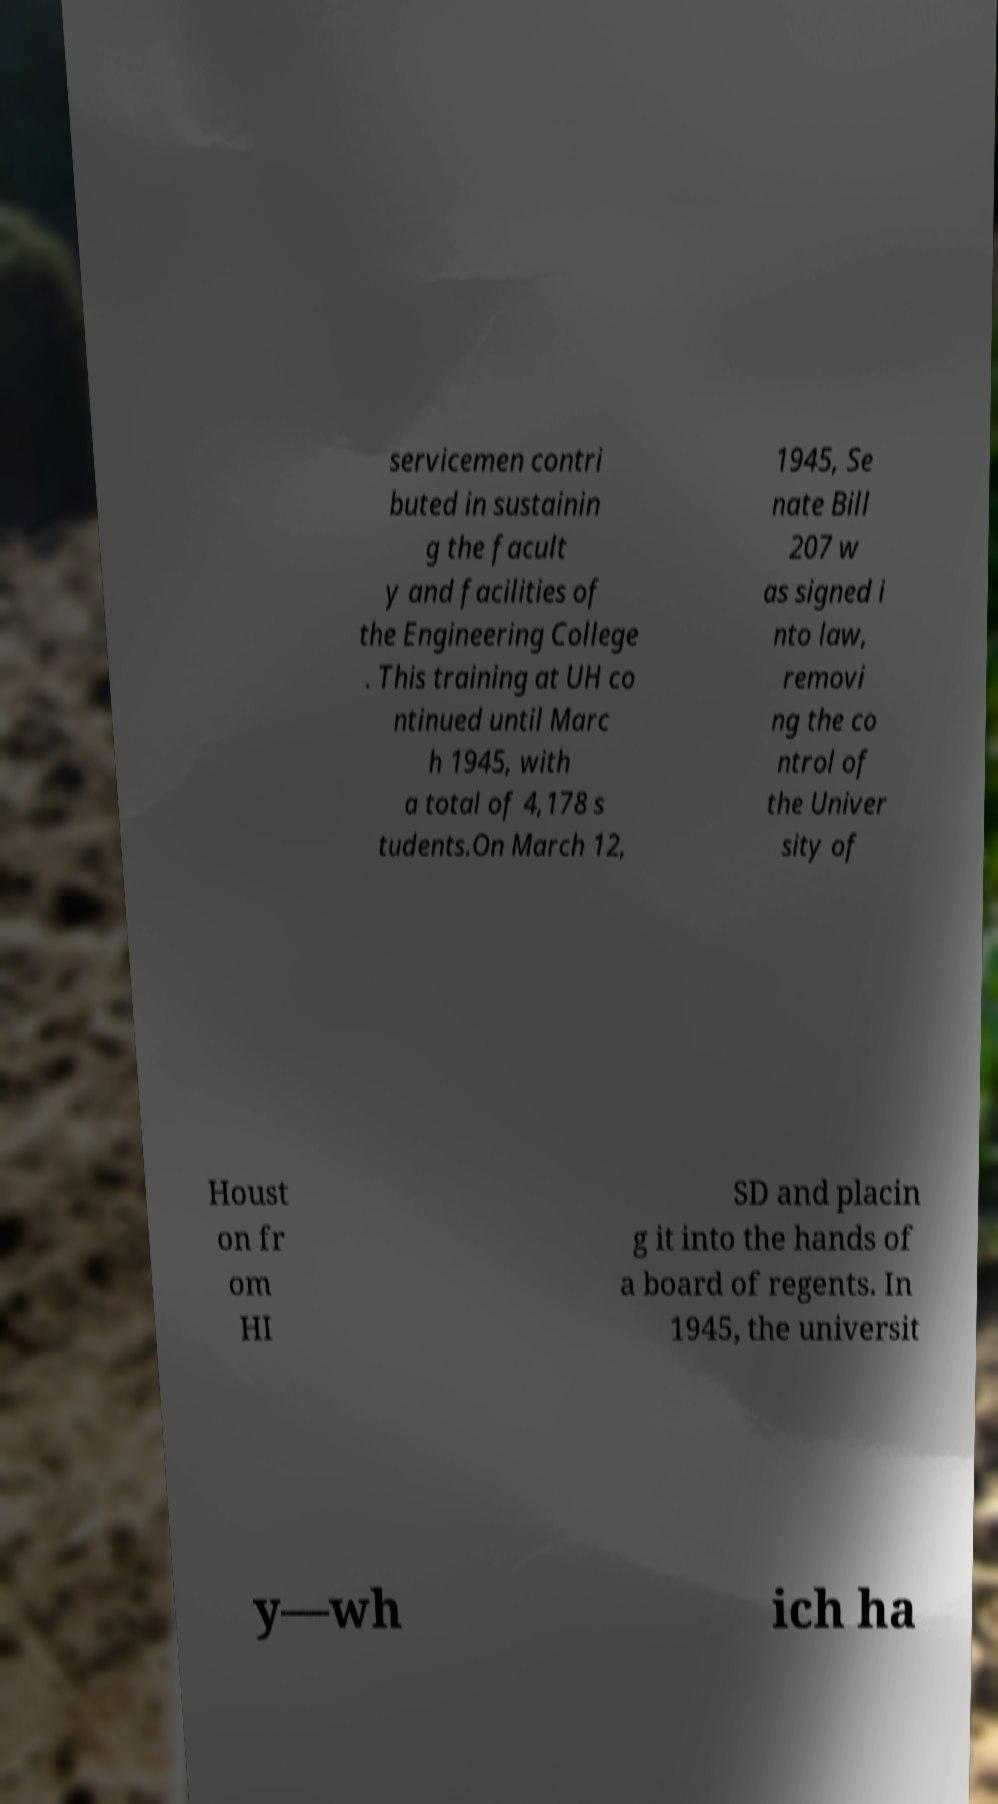I need the written content from this picture converted into text. Can you do that? servicemen contri buted in sustainin g the facult y and facilities of the Engineering College . This training at UH co ntinued until Marc h 1945, with a total of 4,178 s tudents.On March 12, 1945, Se nate Bill 207 w as signed i nto law, removi ng the co ntrol of the Univer sity of Houst on fr om HI SD and placin g it into the hands of a board of regents. In 1945, the universit y—wh ich ha 